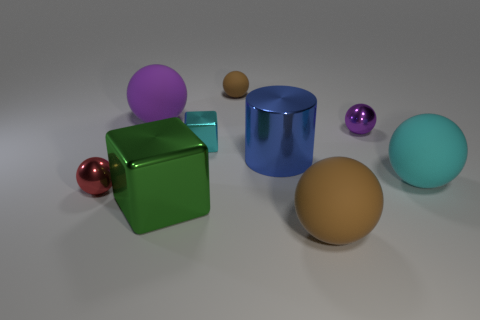Subtract all large purple matte spheres. How many spheres are left? 5 Subtract all brown balls. How many balls are left? 4 Subtract all blue balls. Subtract all green cylinders. How many balls are left? 6 Add 1 shiny blocks. How many objects exist? 10 Subtract all spheres. How many objects are left? 3 Add 6 big gray rubber cubes. How many big gray rubber cubes exist? 6 Subtract 0 brown cylinders. How many objects are left? 9 Subtract all large purple shiny blocks. Subtract all brown things. How many objects are left? 7 Add 5 large brown matte objects. How many large brown matte objects are left? 6 